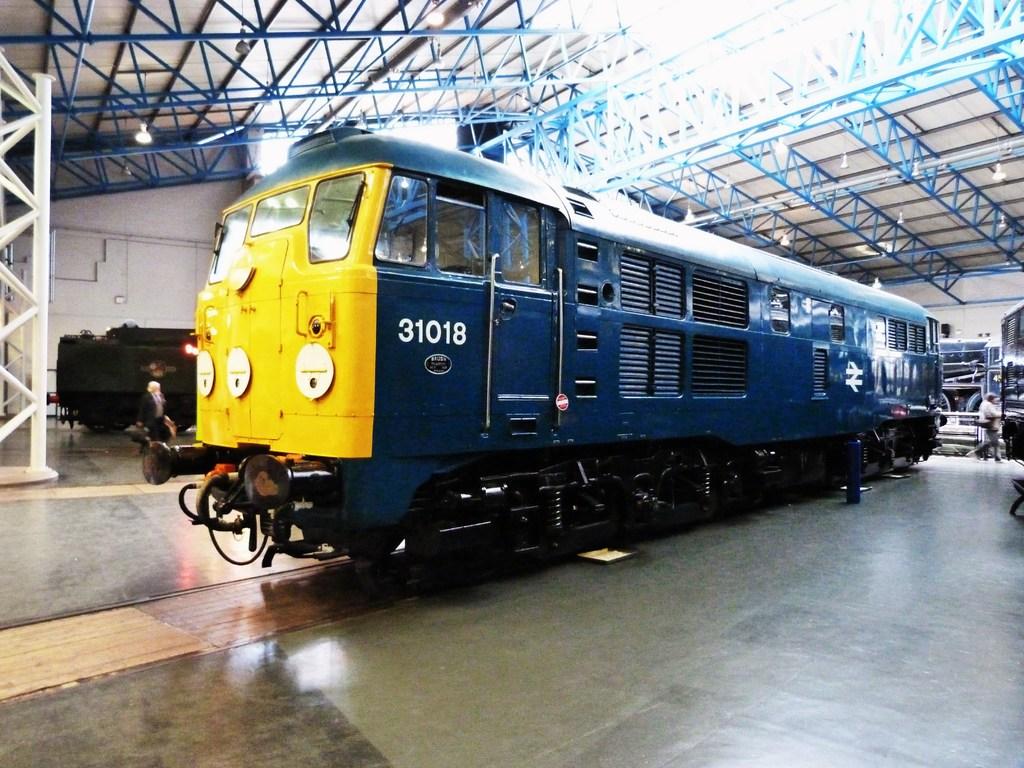What number is on the train?
Give a very brief answer. 31018. 